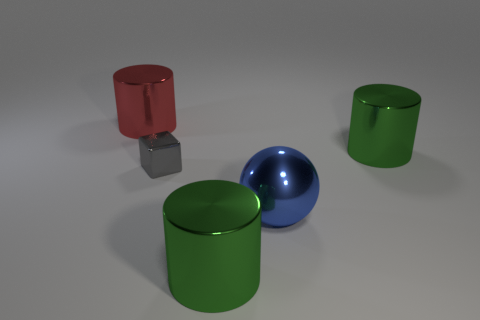Are there more big cylinders in front of the tiny gray cube than big green rubber blocks?
Your answer should be compact. Yes. How many things are green objects that are in front of the small gray block or large red things?
Provide a short and direct response. 2. How many big objects are made of the same material as the tiny gray thing?
Provide a succinct answer. 4. Is there a green metallic thing that has the same shape as the big red thing?
Give a very brief answer. Yes. The red metallic thing that is the same size as the blue object is what shape?
Your answer should be very brief. Cylinder. There is a tiny shiny block; is it the same color as the large cylinder on the right side of the big metallic ball?
Offer a terse response. No. What number of green things are behind the metallic object that is to the left of the shiny block?
Give a very brief answer. 0. There is a object that is both behind the gray shiny object and to the right of the gray shiny cube; what is its size?
Your response must be concise. Large. Are there any rubber cubes that have the same size as the gray metallic cube?
Provide a short and direct response. No. Are there more large objects that are right of the small metal thing than metal blocks that are behind the red metallic cylinder?
Offer a very short reply. Yes. 